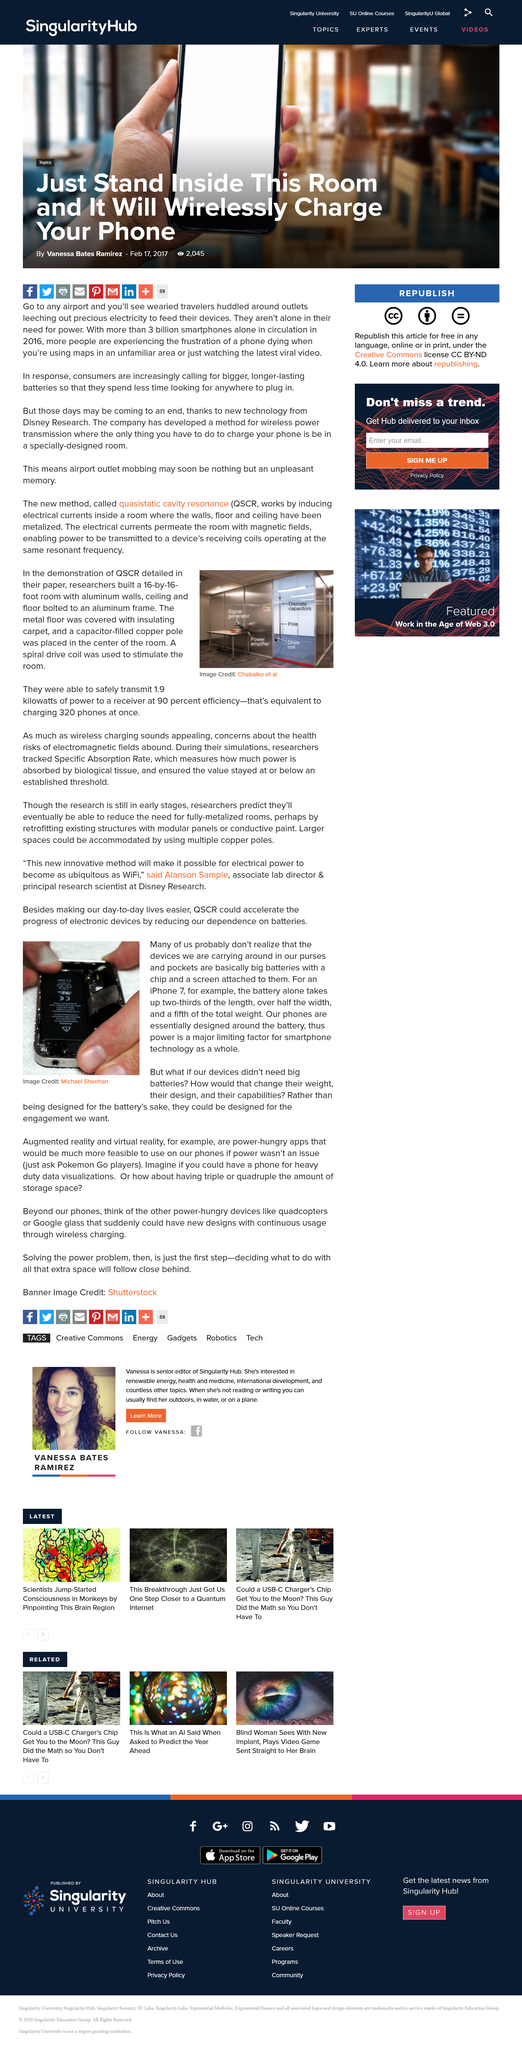Highlight a few significant elements in this photo. Researchers successfully transmitted 1.9 kilowatts of power with 90% efficiency, which demonstrates the potential for safe and efficient power transmission through mid-air charging technology. The battery in an iPhone is proportionally larger than the length of the device, taking up approximately two-thirds of its overall length. The photo was taken by Chabalko et al., and photo credit was given to them. In Michael Sheehan's photograph, the battery is black. The battery in an iPhone takes up about a fifth of the total weight of the device. 